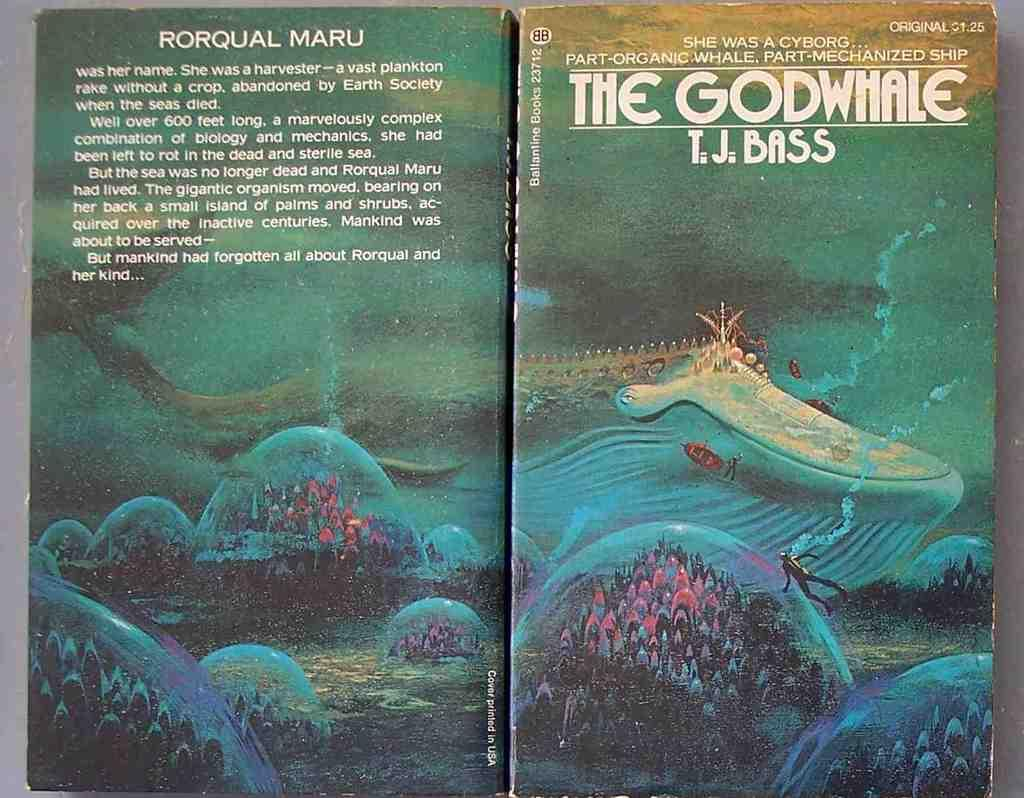<image>
Provide a brief description of the given image. The Godwhale by T.J. Bass shows a whale on the cover. 